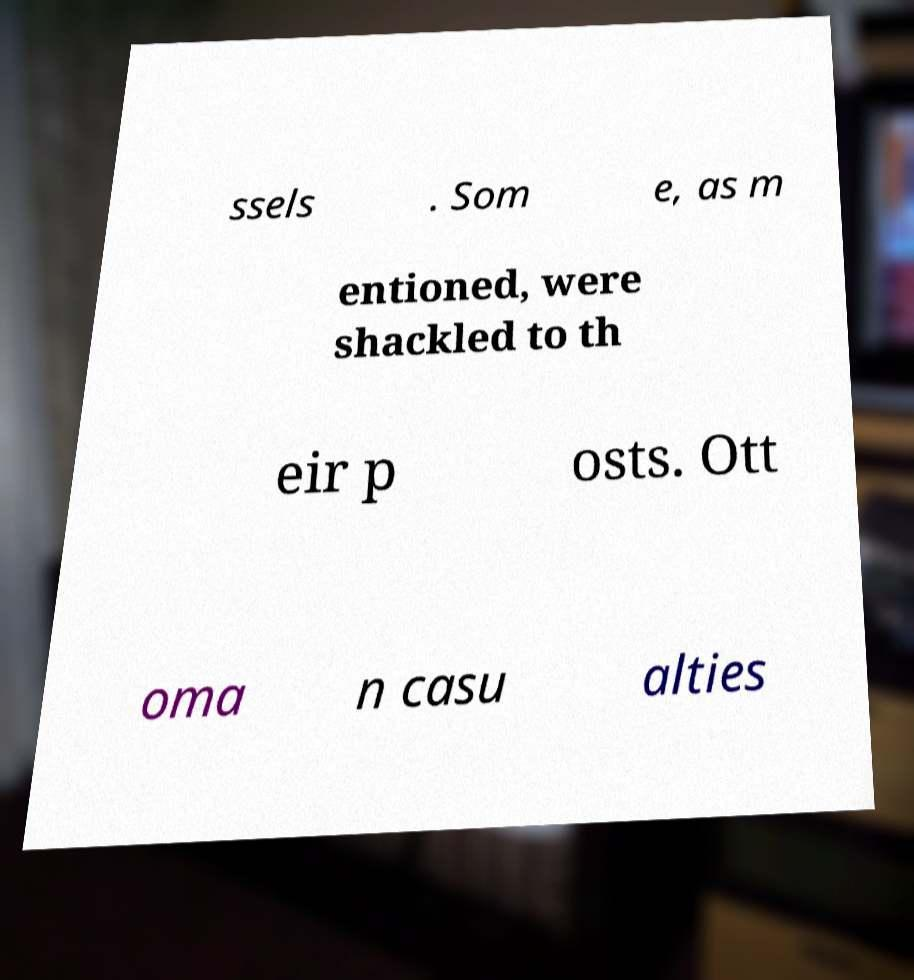What messages or text are displayed in this image? I need them in a readable, typed format. ssels . Som e, as m entioned, were shackled to th eir p osts. Ott oma n casu alties 